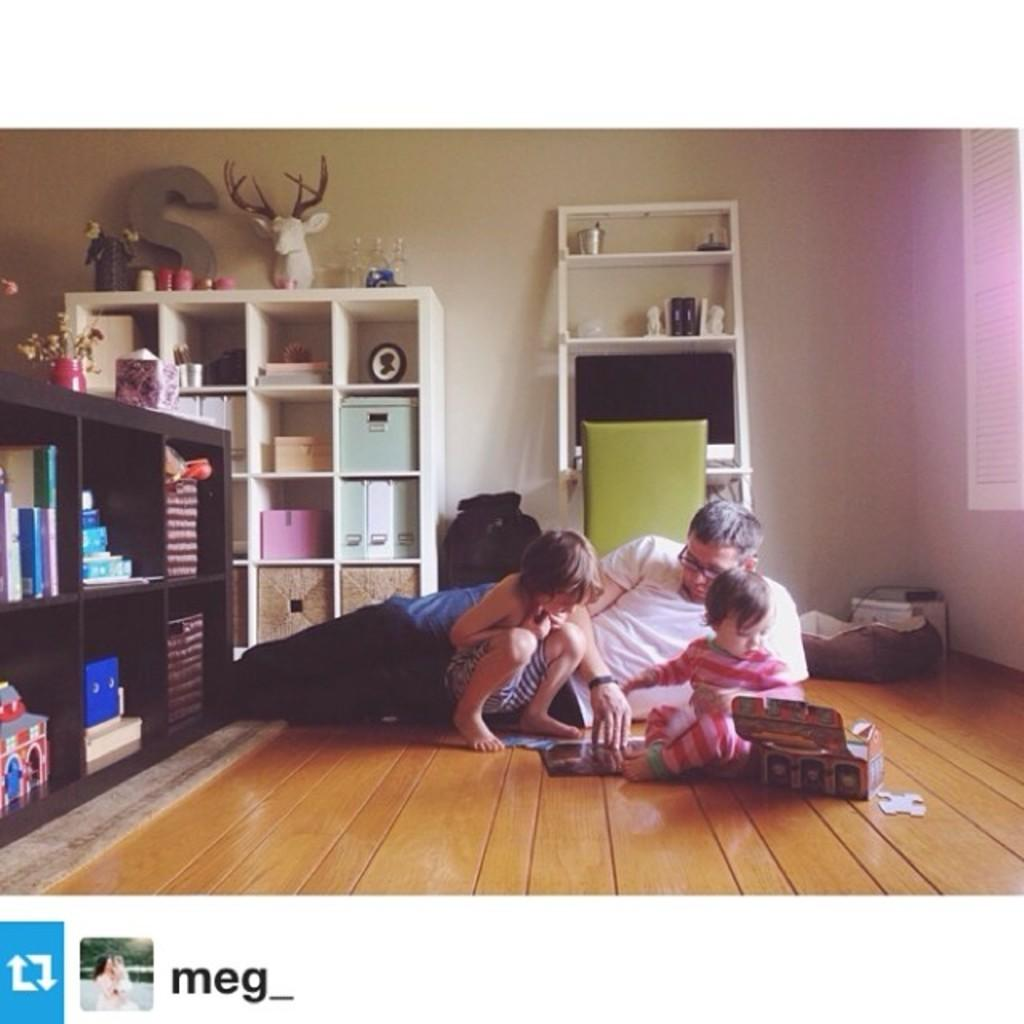<image>
Write a terse but informative summary of the picture. A man and two young girls play on the floor in a photo that was shared by meg_. 